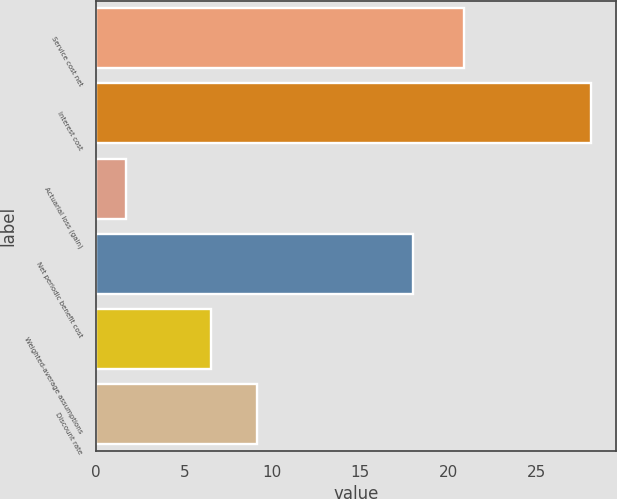<chart> <loc_0><loc_0><loc_500><loc_500><bar_chart><fcel>Service cost net<fcel>Interest cost<fcel>Actuarial loss (gain)<fcel>Net periodic benefit cost<fcel>Weighted-average assumptions<fcel>Discount rate<nl><fcel>20.9<fcel>28.1<fcel>1.7<fcel>18<fcel>6.5<fcel>9.14<nl></chart> 